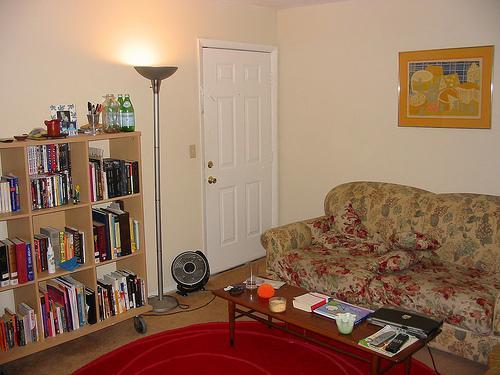How many remote controls do you see?
Give a very brief answer. 2. 